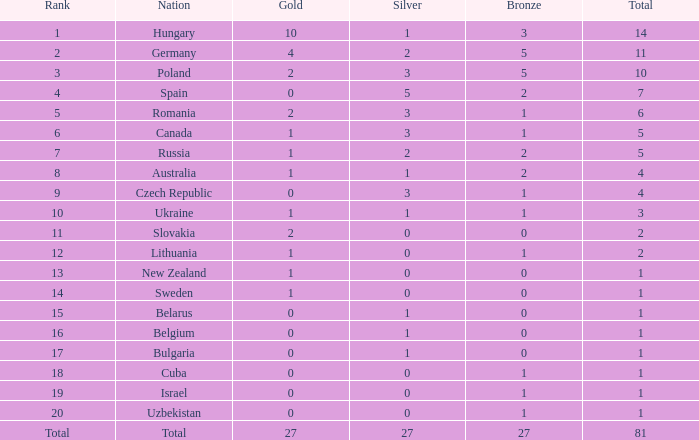How much Silver has a Rank of 1, and a Bronze smaller than 3? None. 